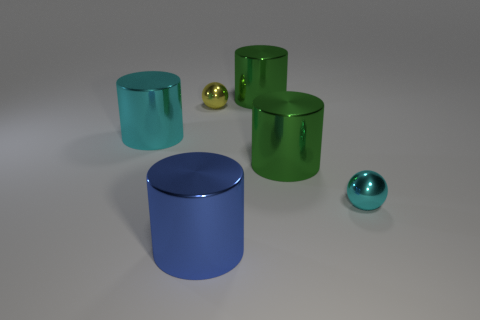Subtract all gray cylinders. Subtract all red spheres. How many cylinders are left? 4 Add 1 shiny cylinders. How many objects exist? 7 Subtract all balls. How many objects are left? 4 Subtract 0 purple cubes. How many objects are left? 6 Subtract all tiny metal spheres. Subtract all tiny red rubber balls. How many objects are left? 4 Add 4 tiny metal objects. How many tiny metal objects are left? 6 Add 6 tiny shiny things. How many tiny shiny things exist? 8 